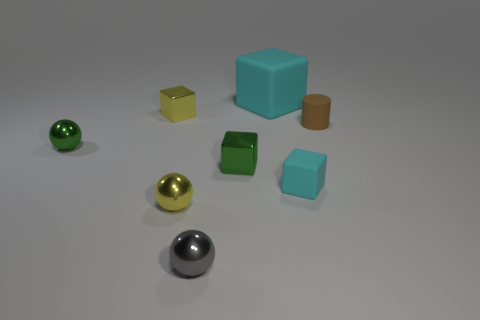Subtract 1 cubes. How many cubes are left? 3 Subtract all blue blocks. Subtract all red spheres. How many blocks are left? 4 Add 2 small green metallic things. How many objects exist? 10 Subtract all spheres. How many objects are left? 5 Add 1 yellow metallic things. How many yellow metallic things are left? 3 Add 8 brown matte cylinders. How many brown matte cylinders exist? 9 Subtract 0 purple cylinders. How many objects are left? 8 Subtract all tiny green things. Subtract all brown balls. How many objects are left? 6 